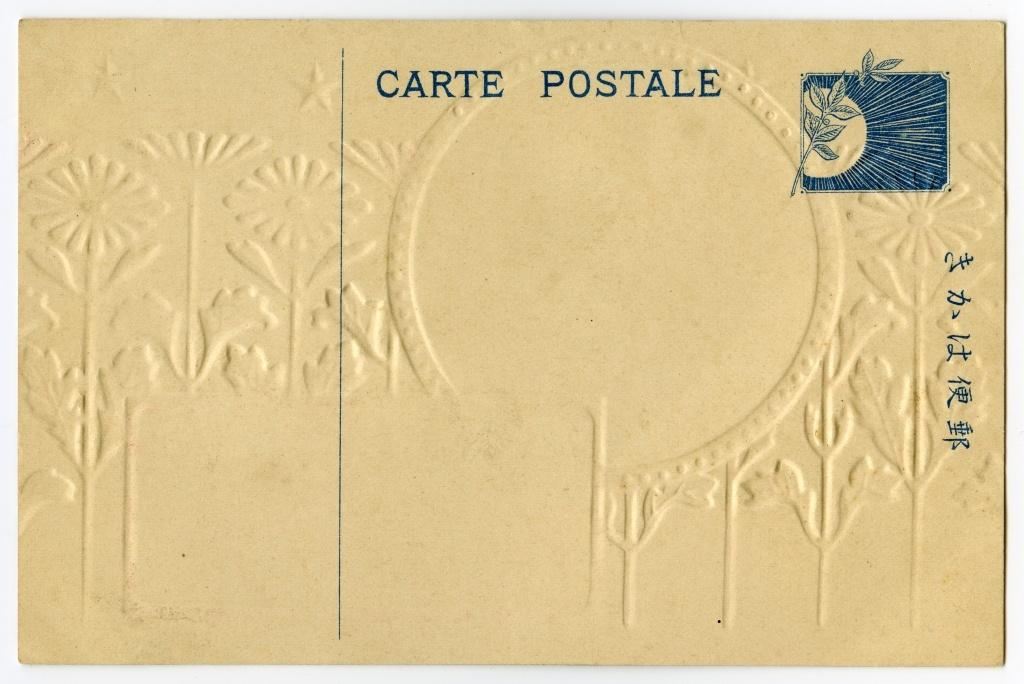<image>
Share a concise interpretation of the image provided. An embossed envelope has been stamped Carte Postale. 